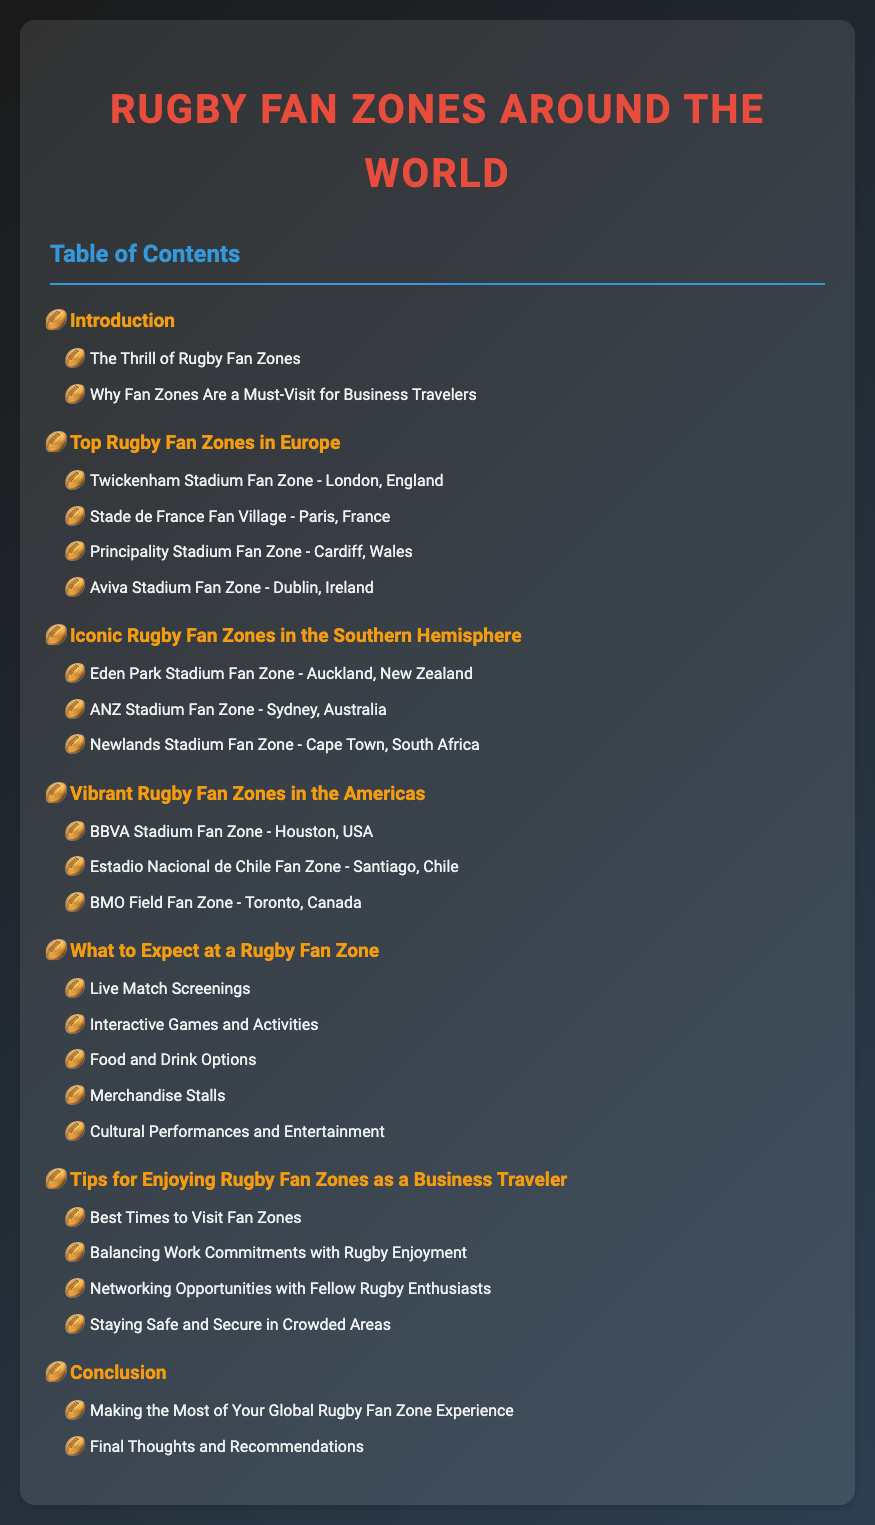what is the title of the document? The title is prominently displayed at the top of the document.
Answer: Rugby Fan Zones Around the World how many chapters are listed in the Table of Contents? The chapters are identified under their respective sections in the Table of Contents.
Answer: 7 which country is home to the Principality Stadium Fan Zone? The country's name is mentioned next to the fan zone location in the document.
Answer: Wales what type of activities can you expect at a Rugby Fan Zone? These activities are outlined in a specific section of the Table of Contents.
Answer: Interactive Games and Activities what is one tip for enjoying Rugby Fan Zones as a business traveler? Tips for business travelers are listed in a dedicated chapter.
Answer: Balancing Work Commitments with Rugby Enjoyment which stadium is the fan zone located in Sydney, Australia? The document specifies this information under the Southern Hemisphere fan zones.
Answer: ANZ Stadium what is the color of the chapter headers? The color of chapter headers is explicitly defined in the document.
Answer: #f39c12 what is the primary theme of the document? The theme can be inferred from the title and content structure.
Answer: Rugby Fan Zones 